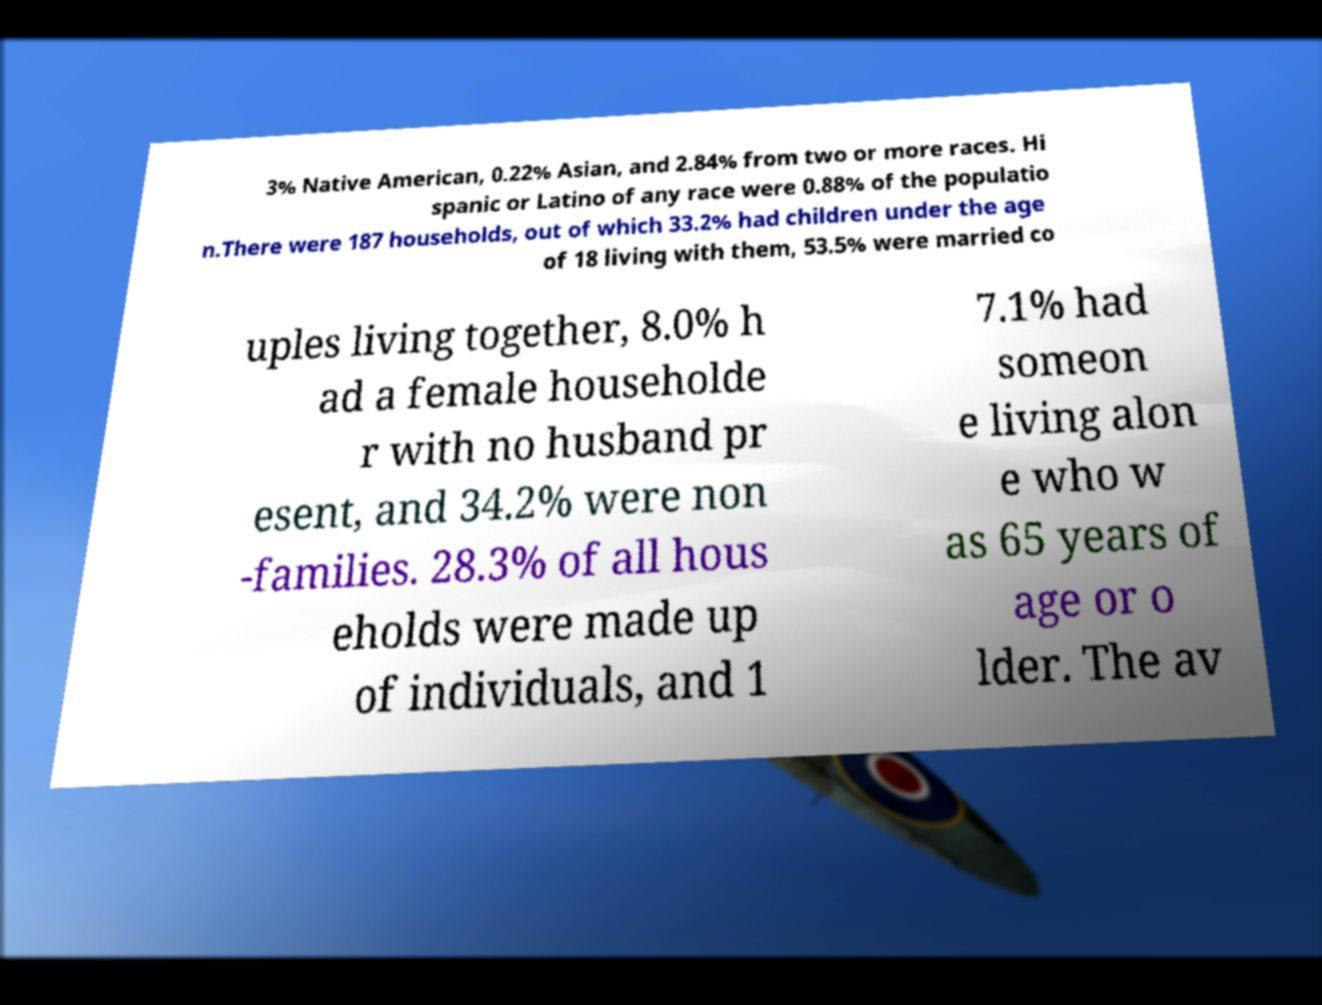I need the written content from this picture converted into text. Can you do that? 3% Native American, 0.22% Asian, and 2.84% from two or more races. Hi spanic or Latino of any race were 0.88% of the populatio n.There were 187 households, out of which 33.2% had children under the age of 18 living with them, 53.5% were married co uples living together, 8.0% h ad a female householde r with no husband pr esent, and 34.2% were non -families. 28.3% of all hous eholds were made up of individuals, and 1 7.1% had someon e living alon e who w as 65 years of age or o lder. The av 